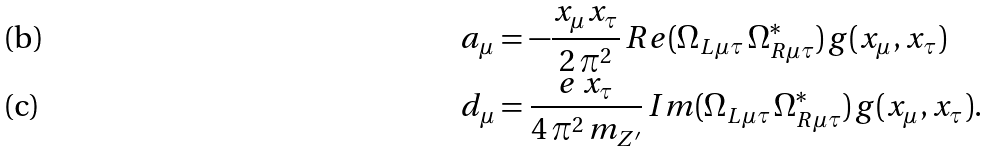Convert formula to latex. <formula><loc_0><loc_0><loc_500><loc_500>a _ { \mu } & = - \frac { x _ { \mu } x _ { \tau } } { 2 \, \pi ^ { 2 } } \, R e ( \Omega _ { L \mu \tau } \, \Omega _ { R \mu \tau } ^ { \ast } ) \, g ( x _ { \mu } , x _ { \tau } ) \\ d _ { \mu } & = \frac { e \, x _ { \tau } } { 4 \, \pi ^ { 2 } \, m _ { Z ^ { \prime } } } \, I m ( \Omega _ { L \mu \tau } \, \Omega _ { R \mu \tau } ^ { \ast } ) \, g ( x _ { \mu } , x _ { \tau } ) .</formula> 